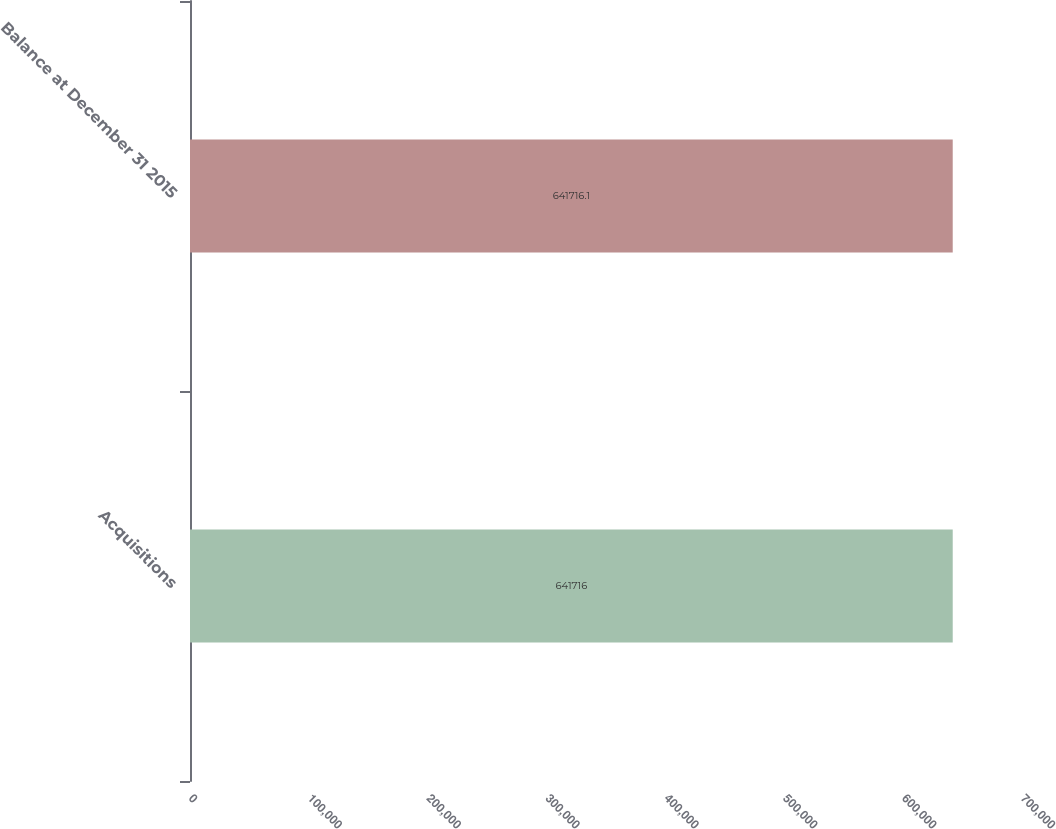Convert chart to OTSL. <chart><loc_0><loc_0><loc_500><loc_500><bar_chart><fcel>Acquisitions<fcel>Balance at December 31 2015<nl><fcel>641716<fcel>641716<nl></chart> 